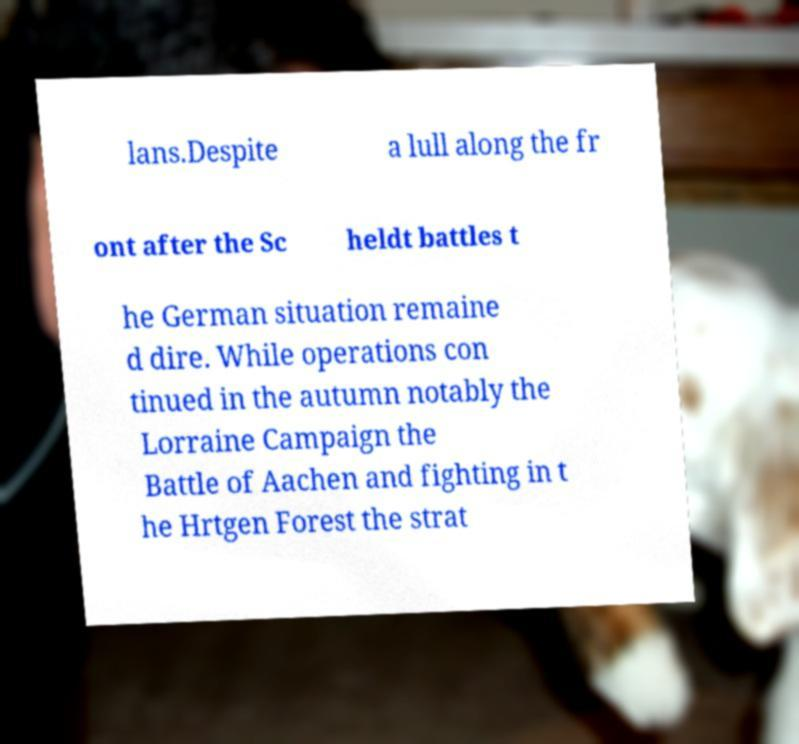What messages or text are displayed in this image? I need them in a readable, typed format. lans.Despite a lull along the fr ont after the Sc heldt battles t he German situation remaine d dire. While operations con tinued in the autumn notably the Lorraine Campaign the Battle of Aachen and fighting in t he Hrtgen Forest the strat 